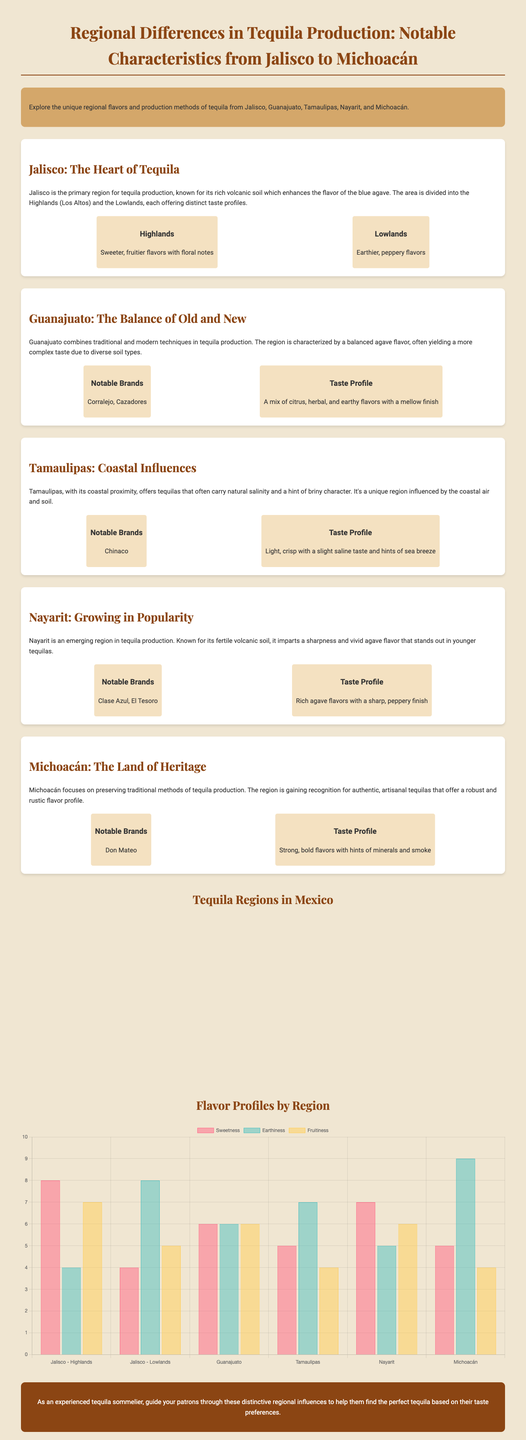What region is known as the heart of tequila? The document states that Jalisco is referred to as the primary region for tequila production and known as the heart of tequila.
Answer: Jalisco What are the notable brands from Guanajuato? The infographic lists Corralejo and Cazadores as notable brands from Guanajuato.
Answer: Corralejo, Cazadores Which tequila region is characterized by coastal influences? The document describes Tamaulipas as having natural salinity and a hint of briny character due to its coastal proximity.
Answer: Tamaulipas What is the sweetness rating for Jalisco Highlands? The bar chart indicates the sweetness rating for Jalisco - Highlands as 8.
Answer: 8 Which region's tequila offers strong, bold flavors? The document states that Michoacán is known for its robust and rustic flavor profile in tequilas.
Answer: Michoacán What taste profile is noted for tequila from Nayarit? According to the text, Nayarit is noted for rich agave flavors with a sharp, peppery finish.
Answer: Rich agave flavors with a sharp, peppery finish How many regions are highlighted in the infographic? The document lists five distinct tequila regions: Jalisco, Guanajuato, Tamaulipas, Nayarit, and Michoacán.
Answer: Five What flavor profile is most prominent in the Lowlands of Jalisco? The infographic describes the Lowlands of Jalisco as having earthy, peppery flavors.
Answer: Earthy, peppery flavors What flavor score for earthiness does Michoacán receive in the chart? The bar chart shows that Michoacán has an earthiness score of 9.
Answer: 9 